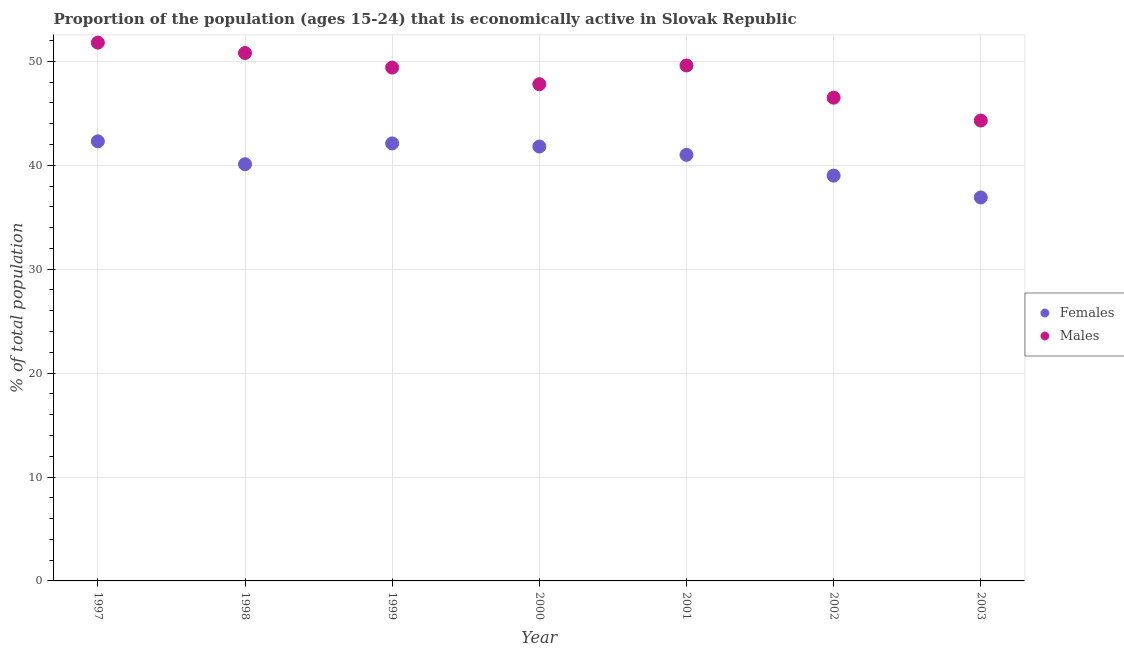What is the percentage of economically active male population in 2000?
Offer a very short reply. 47.8. Across all years, what is the maximum percentage of economically active male population?
Your response must be concise. 51.8. Across all years, what is the minimum percentage of economically active female population?
Offer a terse response. 36.9. In which year was the percentage of economically active male population minimum?
Make the answer very short. 2003. What is the total percentage of economically active male population in the graph?
Keep it short and to the point. 340.2. What is the difference between the percentage of economically active female population in 1997 and that in 1998?
Keep it short and to the point. 2.2. What is the difference between the percentage of economically active male population in 1999 and the percentage of economically active female population in 2002?
Your answer should be compact. 10.4. What is the average percentage of economically active male population per year?
Make the answer very short. 48.6. In the year 2001, what is the difference between the percentage of economically active female population and percentage of economically active male population?
Your answer should be compact. -8.6. What is the ratio of the percentage of economically active male population in 1999 to that in 2003?
Your answer should be very brief. 1.12. Is the difference between the percentage of economically active female population in 1997 and 2000 greater than the difference between the percentage of economically active male population in 1997 and 2000?
Your response must be concise. No. What is the difference between the highest and the lowest percentage of economically active female population?
Keep it short and to the point. 5.4. Is the sum of the percentage of economically active female population in 2002 and 2003 greater than the maximum percentage of economically active male population across all years?
Your response must be concise. Yes. Is the percentage of economically active female population strictly greater than the percentage of economically active male population over the years?
Offer a very short reply. No. How many years are there in the graph?
Ensure brevity in your answer.  7. What is the difference between two consecutive major ticks on the Y-axis?
Give a very brief answer. 10. Are the values on the major ticks of Y-axis written in scientific E-notation?
Provide a short and direct response. No. Does the graph contain any zero values?
Give a very brief answer. No. How many legend labels are there?
Provide a short and direct response. 2. What is the title of the graph?
Your answer should be very brief. Proportion of the population (ages 15-24) that is economically active in Slovak Republic. What is the label or title of the Y-axis?
Your answer should be very brief. % of total population. What is the % of total population of Females in 1997?
Offer a terse response. 42.3. What is the % of total population of Males in 1997?
Ensure brevity in your answer.  51.8. What is the % of total population in Females in 1998?
Provide a short and direct response. 40.1. What is the % of total population in Males in 1998?
Offer a terse response. 50.8. What is the % of total population in Females in 1999?
Provide a succinct answer. 42.1. What is the % of total population in Males in 1999?
Keep it short and to the point. 49.4. What is the % of total population of Females in 2000?
Provide a succinct answer. 41.8. What is the % of total population in Males in 2000?
Offer a terse response. 47.8. What is the % of total population in Females in 2001?
Make the answer very short. 41. What is the % of total population of Males in 2001?
Make the answer very short. 49.6. What is the % of total population in Males in 2002?
Your answer should be very brief. 46.5. What is the % of total population in Females in 2003?
Provide a short and direct response. 36.9. What is the % of total population of Males in 2003?
Keep it short and to the point. 44.3. Across all years, what is the maximum % of total population of Females?
Ensure brevity in your answer.  42.3. Across all years, what is the maximum % of total population in Males?
Your answer should be compact. 51.8. Across all years, what is the minimum % of total population in Females?
Provide a succinct answer. 36.9. Across all years, what is the minimum % of total population of Males?
Keep it short and to the point. 44.3. What is the total % of total population in Females in the graph?
Make the answer very short. 283.2. What is the total % of total population in Males in the graph?
Your answer should be compact. 340.2. What is the difference between the % of total population in Females in 1997 and that in 1998?
Offer a very short reply. 2.2. What is the difference between the % of total population in Males in 1997 and that in 1999?
Your answer should be very brief. 2.4. What is the difference between the % of total population in Males in 1997 and that in 2000?
Your response must be concise. 4. What is the difference between the % of total population in Males in 1997 and that in 2002?
Your answer should be very brief. 5.3. What is the difference between the % of total population in Females in 1997 and that in 2003?
Your response must be concise. 5.4. What is the difference between the % of total population of Females in 1998 and that in 2000?
Your answer should be very brief. -1.7. What is the difference between the % of total population in Males in 1998 and that in 2000?
Ensure brevity in your answer.  3. What is the difference between the % of total population in Males in 1998 and that in 2001?
Keep it short and to the point. 1.2. What is the difference between the % of total population in Males in 1998 and that in 2003?
Provide a short and direct response. 6.5. What is the difference between the % of total population in Males in 1999 and that in 2001?
Keep it short and to the point. -0.2. What is the difference between the % of total population of Females in 1999 and that in 2002?
Provide a short and direct response. 3.1. What is the difference between the % of total population in Males in 1999 and that in 2003?
Provide a short and direct response. 5.1. What is the difference between the % of total population of Females in 2000 and that in 2001?
Make the answer very short. 0.8. What is the difference between the % of total population of Females in 2000 and that in 2002?
Make the answer very short. 2.8. What is the difference between the % of total population of Females in 2000 and that in 2003?
Make the answer very short. 4.9. What is the difference between the % of total population in Males in 2000 and that in 2003?
Ensure brevity in your answer.  3.5. What is the difference between the % of total population in Females in 2001 and that in 2002?
Give a very brief answer. 2. What is the difference between the % of total population of Males in 2001 and that in 2002?
Offer a very short reply. 3.1. What is the difference between the % of total population of Females in 2001 and that in 2003?
Ensure brevity in your answer.  4.1. What is the difference between the % of total population of Males in 2001 and that in 2003?
Your answer should be very brief. 5.3. What is the difference between the % of total population of Females in 2002 and that in 2003?
Your answer should be compact. 2.1. What is the difference between the % of total population in Males in 2002 and that in 2003?
Your answer should be very brief. 2.2. What is the difference between the % of total population of Females in 1997 and the % of total population of Males in 1998?
Make the answer very short. -8.5. What is the difference between the % of total population in Females in 1997 and the % of total population in Males in 1999?
Give a very brief answer. -7.1. What is the difference between the % of total population in Females in 1997 and the % of total population in Males in 2001?
Offer a very short reply. -7.3. What is the difference between the % of total population in Females in 1997 and the % of total population in Males in 2002?
Make the answer very short. -4.2. What is the difference between the % of total population of Females in 1998 and the % of total population of Males in 1999?
Your response must be concise. -9.3. What is the difference between the % of total population in Females in 1998 and the % of total population in Males in 2000?
Your response must be concise. -7.7. What is the difference between the % of total population in Females in 1998 and the % of total population in Males in 2002?
Make the answer very short. -6.4. What is the difference between the % of total population of Females in 1998 and the % of total population of Males in 2003?
Your answer should be very brief. -4.2. What is the difference between the % of total population of Females in 1999 and the % of total population of Males in 2002?
Keep it short and to the point. -4.4. What is the difference between the % of total population of Females in 2000 and the % of total population of Males in 2001?
Ensure brevity in your answer.  -7.8. What is the difference between the % of total population in Females in 2000 and the % of total population in Males in 2002?
Make the answer very short. -4.7. What is the difference between the % of total population of Females in 2000 and the % of total population of Males in 2003?
Your response must be concise. -2.5. What is the difference between the % of total population of Females in 2001 and the % of total population of Males in 2003?
Ensure brevity in your answer.  -3.3. What is the average % of total population in Females per year?
Your response must be concise. 40.46. What is the average % of total population in Males per year?
Give a very brief answer. 48.6. In the year 1999, what is the difference between the % of total population in Females and % of total population in Males?
Provide a short and direct response. -7.3. In the year 2000, what is the difference between the % of total population of Females and % of total population of Males?
Offer a very short reply. -6. In the year 2002, what is the difference between the % of total population in Females and % of total population in Males?
Ensure brevity in your answer.  -7.5. In the year 2003, what is the difference between the % of total population of Females and % of total population of Males?
Make the answer very short. -7.4. What is the ratio of the % of total population in Females in 1997 to that in 1998?
Ensure brevity in your answer.  1.05. What is the ratio of the % of total population in Males in 1997 to that in 1998?
Provide a short and direct response. 1.02. What is the ratio of the % of total population in Females in 1997 to that in 1999?
Provide a short and direct response. 1. What is the ratio of the % of total population in Males in 1997 to that in 1999?
Make the answer very short. 1.05. What is the ratio of the % of total population in Males in 1997 to that in 2000?
Offer a very short reply. 1.08. What is the ratio of the % of total population of Females in 1997 to that in 2001?
Offer a terse response. 1.03. What is the ratio of the % of total population of Males in 1997 to that in 2001?
Offer a terse response. 1.04. What is the ratio of the % of total population in Females in 1997 to that in 2002?
Your response must be concise. 1.08. What is the ratio of the % of total population of Males in 1997 to that in 2002?
Make the answer very short. 1.11. What is the ratio of the % of total population of Females in 1997 to that in 2003?
Your response must be concise. 1.15. What is the ratio of the % of total population of Males in 1997 to that in 2003?
Provide a succinct answer. 1.17. What is the ratio of the % of total population in Females in 1998 to that in 1999?
Keep it short and to the point. 0.95. What is the ratio of the % of total population of Males in 1998 to that in 1999?
Your answer should be very brief. 1.03. What is the ratio of the % of total population in Females in 1998 to that in 2000?
Your answer should be compact. 0.96. What is the ratio of the % of total population in Males in 1998 to that in 2000?
Make the answer very short. 1.06. What is the ratio of the % of total population in Males in 1998 to that in 2001?
Offer a very short reply. 1.02. What is the ratio of the % of total population of Females in 1998 to that in 2002?
Your response must be concise. 1.03. What is the ratio of the % of total population of Males in 1998 to that in 2002?
Your answer should be very brief. 1.09. What is the ratio of the % of total population in Females in 1998 to that in 2003?
Give a very brief answer. 1.09. What is the ratio of the % of total population of Males in 1998 to that in 2003?
Offer a very short reply. 1.15. What is the ratio of the % of total population in Males in 1999 to that in 2000?
Offer a very short reply. 1.03. What is the ratio of the % of total population of Females in 1999 to that in 2001?
Offer a terse response. 1.03. What is the ratio of the % of total population in Males in 1999 to that in 2001?
Keep it short and to the point. 1. What is the ratio of the % of total population of Females in 1999 to that in 2002?
Your answer should be very brief. 1.08. What is the ratio of the % of total population of Males in 1999 to that in 2002?
Make the answer very short. 1.06. What is the ratio of the % of total population of Females in 1999 to that in 2003?
Offer a terse response. 1.14. What is the ratio of the % of total population in Males in 1999 to that in 2003?
Offer a terse response. 1.12. What is the ratio of the % of total population in Females in 2000 to that in 2001?
Offer a very short reply. 1.02. What is the ratio of the % of total population of Males in 2000 to that in 2001?
Provide a short and direct response. 0.96. What is the ratio of the % of total population in Females in 2000 to that in 2002?
Provide a short and direct response. 1.07. What is the ratio of the % of total population in Males in 2000 to that in 2002?
Provide a succinct answer. 1.03. What is the ratio of the % of total population of Females in 2000 to that in 2003?
Offer a terse response. 1.13. What is the ratio of the % of total population of Males in 2000 to that in 2003?
Offer a terse response. 1.08. What is the ratio of the % of total population in Females in 2001 to that in 2002?
Your response must be concise. 1.05. What is the ratio of the % of total population in Males in 2001 to that in 2002?
Provide a succinct answer. 1.07. What is the ratio of the % of total population in Males in 2001 to that in 2003?
Provide a succinct answer. 1.12. What is the ratio of the % of total population in Females in 2002 to that in 2003?
Keep it short and to the point. 1.06. What is the ratio of the % of total population of Males in 2002 to that in 2003?
Make the answer very short. 1.05. What is the difference between the highest and the second highest % of total population of Females?
Your response must be concise. 0.2. What is the difference between the highest and the lowest % of total population in Females?
Keep it short and to the point. 5.4. What is the difference between the highest and the lowest % of total population in Males?
Your response must be concise. 7.5. 